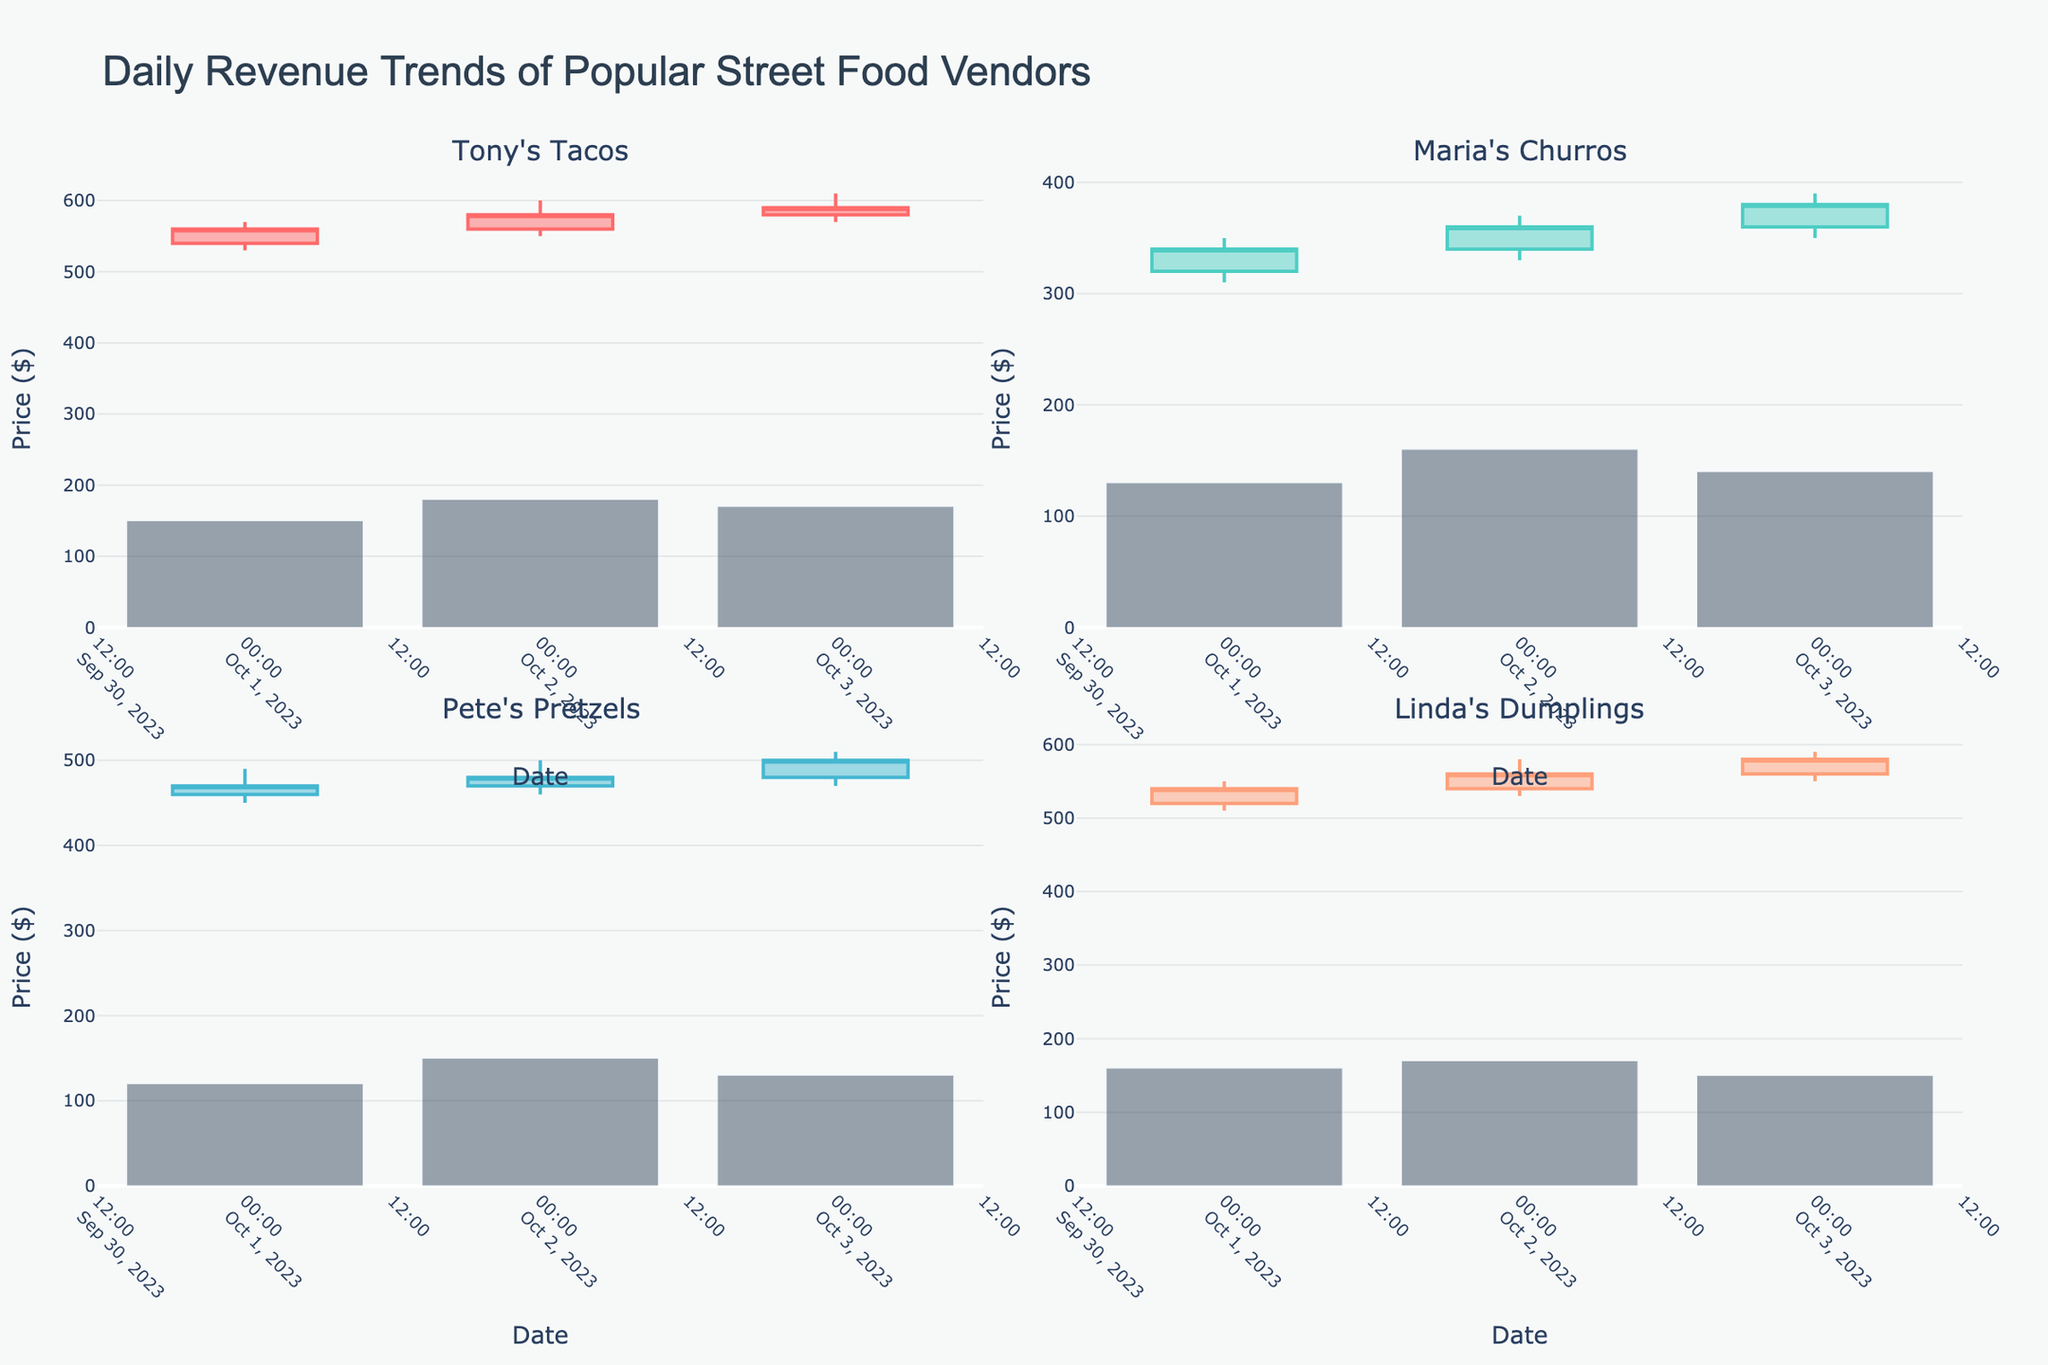How many vendors are represented in the figure? There are four subplots in the figure, each representing a different vendor. The subplot titles i.e., Tony's Tacos, Maria's Churros, Pete's Pretzels, and Linda's Dumplings indicate the number of vendors.
Answer: 4 Which vendor had the highest closing price over the three days? By observing the candlestick plots, each vendor's highest closing price is visible. Tony's Tacos had the highest closing price at $590 on October 3rd.
Answer: Tony's Tacos What is the trend for Tony's Tacos between October 1 and October 3? Tony's Tacos shows an increasing trend in the closing prices for each consecutive day. Specifically, the closing prices are $560 on October 1, $580 on October 2, and $590 on October 3.
Answer: Increasing Which vendor had the lowest volume on October 2? Referring to the volume bars for October 2, Pete's Pretzels had the lowest volume of 150 on that day.
Answer: Pete's Pretzels Compare the closing price of Tony's Tacos on October 1 with Maria's Churros on October 2. Which is higher? Tony's Tacos closed at $560 on October 1, while Maria's Churros closed at $360 on October 2. Therefore, Tony's Tacos' closing price is higher.
Answer: Tony's Tacos What is the average closing price for Linda’s Dumplings over the three days? The closing prices for Linda's Dumplings are $540, $560, and $580. The average is calculated as (540 + 560 + 580) / 3 which equals 560.
Answer: $560 Did any vendor experience a decrease in closing price on any given day? Based on the candlestick plots, none of the vendors experienced a decrease in closing prices between any consecutive days within the observed period.
Answer: No Which vendor showed the highest daily variability in stock prices on a single day, and when? By examining the difference between the high and low prices for each vendor, Tony's Tacos on October 2 had the highest variability with a range from $600 to $550, a difference of $50.
Answer: Tony's Tacos on October 2 What's the total volume for Maria's Churros over the three days? Adding up the volume bars for Maria's Churros, we get 130 + 160 + 140 which equals 430.
Answer: 430 